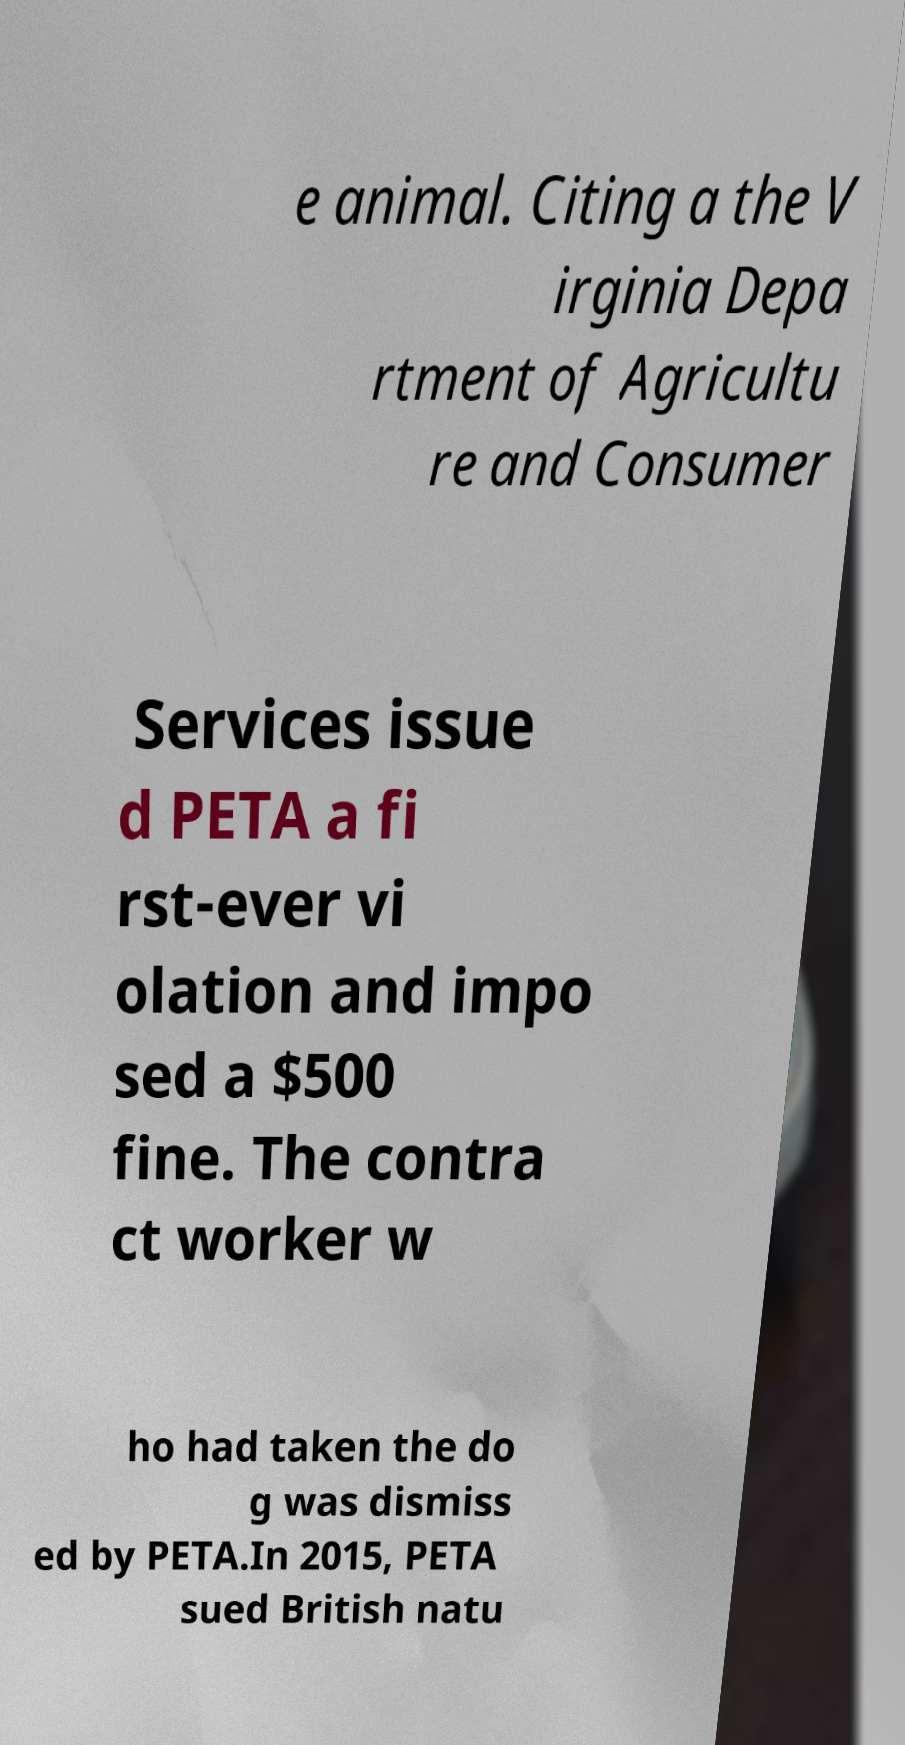Please identify and transcribe the text found in this image. e animal. Citing a the V irginia Depa rtment of Agricultu re and Consumer Services issue d PETA a fi rst-ever vi olation and impo sed a $500 fine. The contra ct worker w ho had taken the do g was dismiss ed by PETA.In 2015, PETA sued British natu 